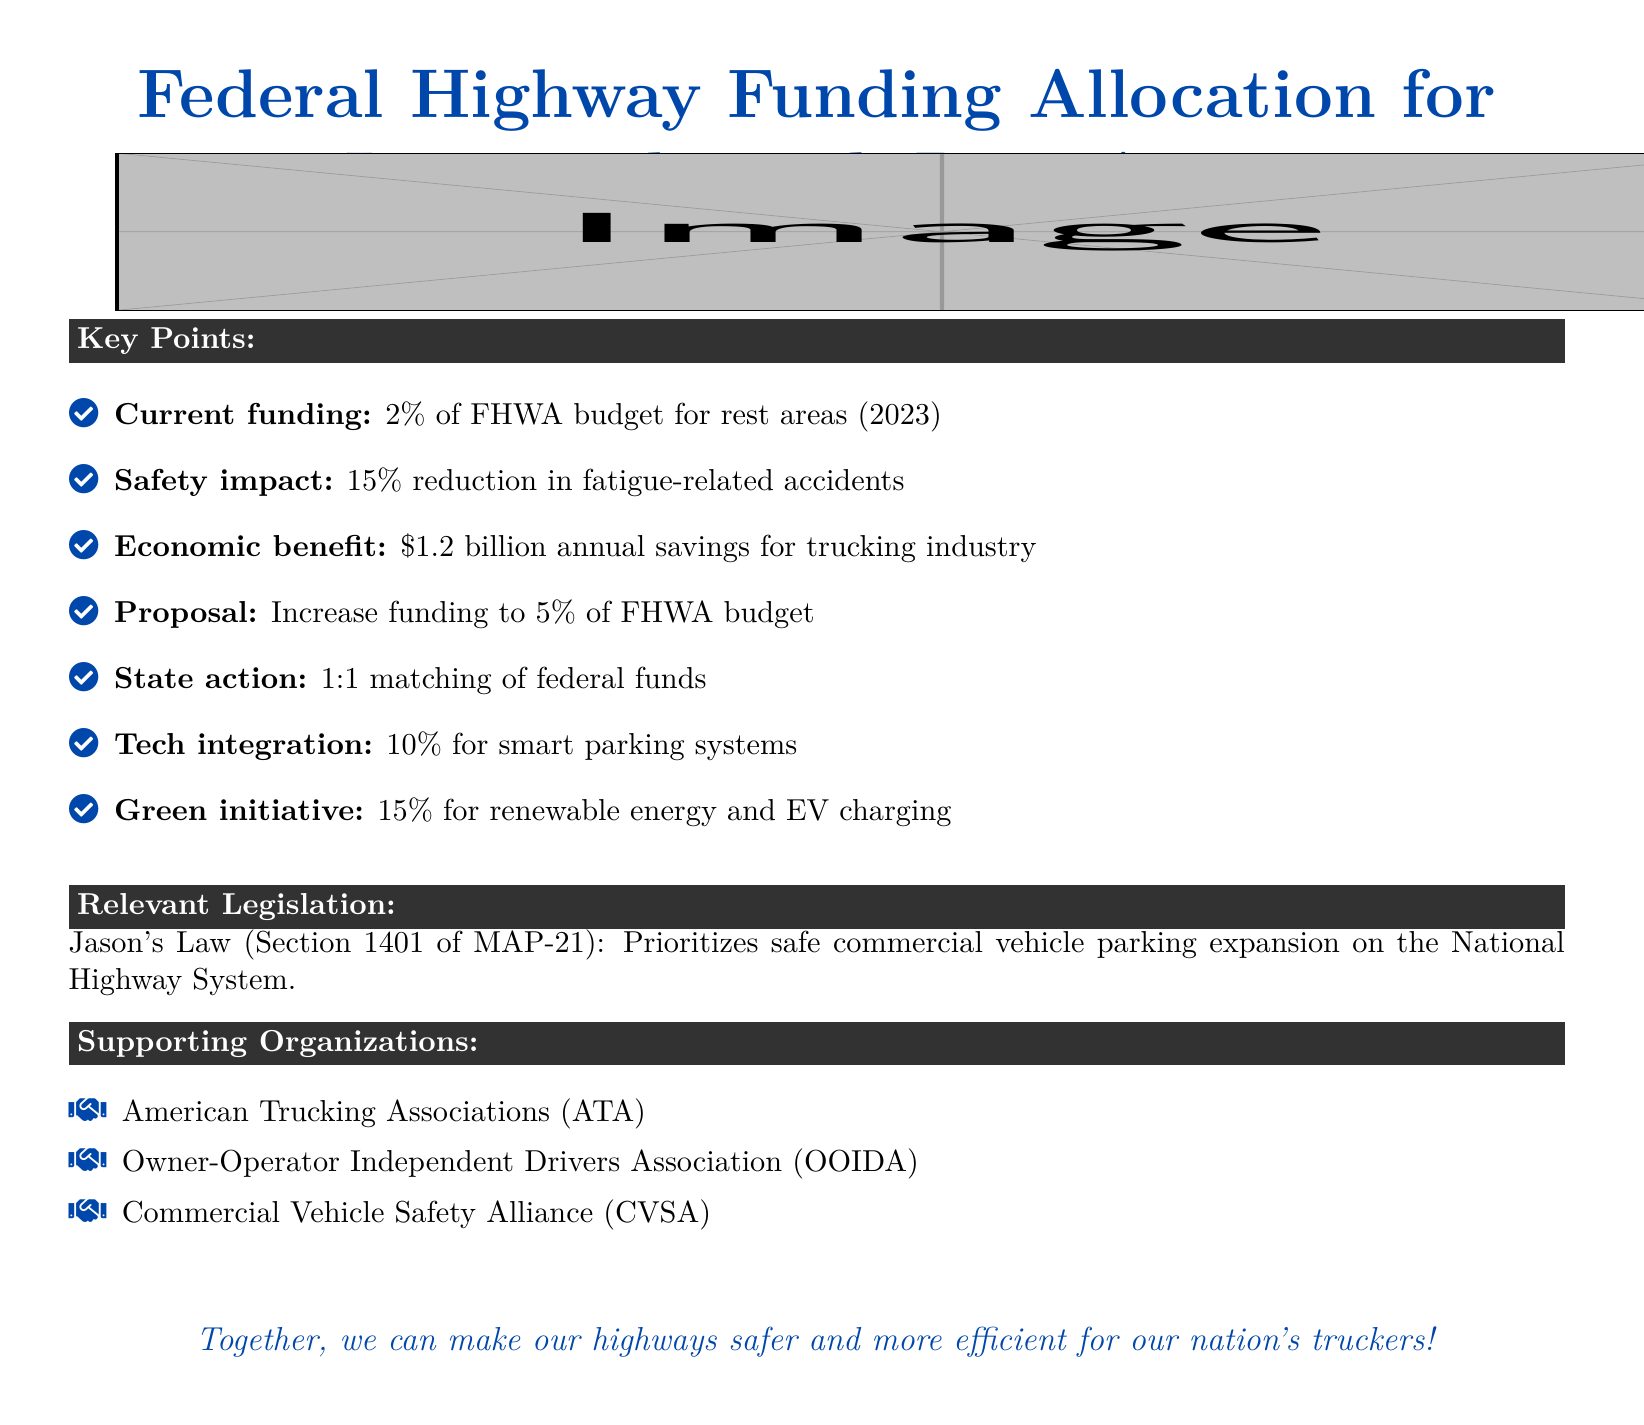What percentage of the FHWA budget is currently allocated for truck rest areas? The document states that 2% of the FHWA budget is currently allocated for rest areas as of 2023.
Answer: 2% What is the proposed percentage increase for funding truck rest areas? The proposal suggests increasing funding to 5% of the FHWA budget.
Answer: 5% What is the estimated annual economic benefit for the trucking industry? The document mentions an economic benefit of $1.2 billion annually for the trucking industry.
Answer: $1.2 billion Which law prioritizes safe commercial vehicle parking expansion? The relevant legislation mentioned is Jason's Law, specifically Section 1401 of MAP-21.
Answer: Jason's Law What percentage of funding is recommended for smart parking systems? The document indicates that 10% of the funding is proposed for smart parking systems.
Answer: 10% What reduction in fatigue-related accidents is attributed to improved rest areas? The safety impact identified in the document is a 15% reduction in fatigue-related accidents.
Answer: 15% Which organization is NOT listed as a supporting organization? The organizations listed are ATA, OOIDA, and CVSA, thus any other organization not mentioned would be the answer.
Answer: N/A (specific organization not provided in the document) What is the 1:1 matching federal fund action proposed for states? The document states that a 1:1 matching of federal funds is proposed for states.
Answer: 1:1 matching What percentage of the funding is allocated for renewable energy and EV charging? The document proposes that 15% of the funding be used for renewable energy and EV charging.
Answer: 15% 